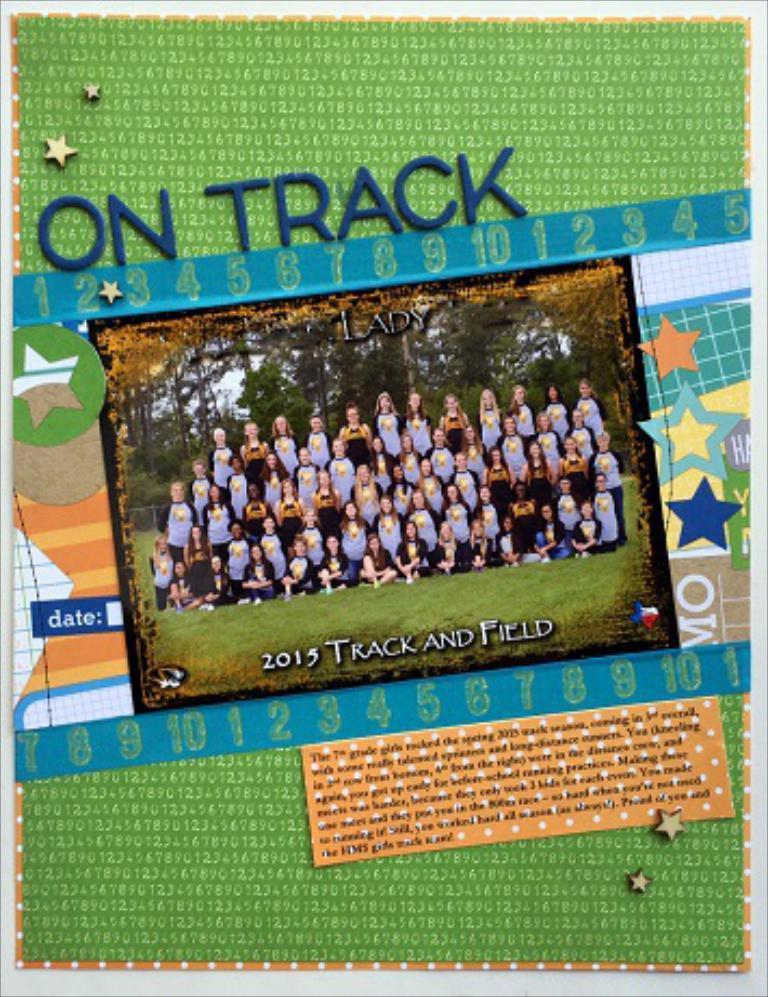Describe this image in one or two sentences. In this picture we can see a photo frame, there are some people standing and sitting here, we can see grass at the bottom, in the background there are some trees, we can see some text here. 